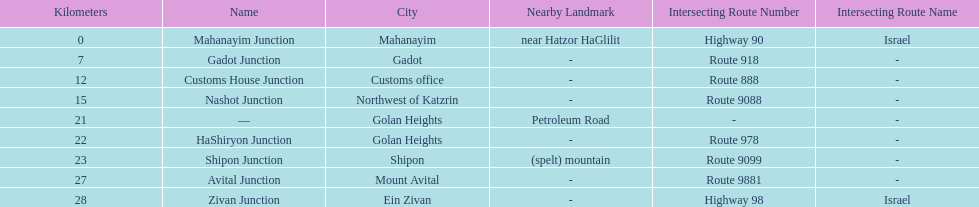Write the full table. {'header': ['Kilometers', 'Name', 'City', 'Nearby Landmark', 'Intersecting Route Number', 'Intersecting Route Name'], 'rows': [['0', 'Mahanayim Junction', 'Mahanayim', 'near Hatzor HaGlilit', 'Highway 90', 'Israel'], ['7', 'Gadot Junction', 'Gadot', '-', 'Route 918', '-'], ['12', 'Customs House Junction', 'Customs office', '-', 'Route 888', '-'], ['15', 'Nashot Junction', 'Northwest of Katzrin', '-', 'Route 9088', '-'], ['21', '—', 'Golan Heights', 'Petroleum Road', '-', '-'], ['22', 'HaShiryon Junction', 'Golan Heights', '-', 'Route 978', '-'], ['23', 'Shipon Junction', 'Shipon', '(spelt) mountain', 'Route 9099', '-'], ['27', 'Avital Junction', 'Mount Avital', '-', 'Route 9881', '-'], ['28', 'Zivan Junction', 'Ein Zivan', '-', 'Highway 98', 'Israel']]} Which junction on highway 91 is closer to ein zivan, gadot junction or shipon junction? Gadot Junction. 